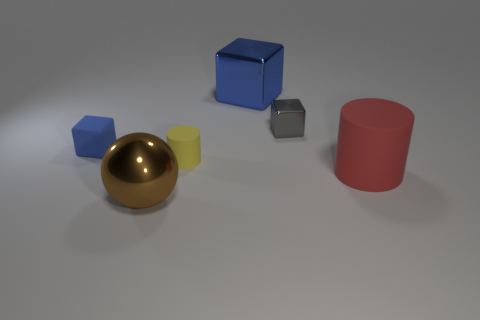What shapes and colors do you observe in the image? The image includes a variety of geometric shapes: a red cylinder, a gold sphere, a yellow and a silver cube, and a blue cube with rounded edges. The colors range from a vibrant blue and red to the more subtle gold, silver, and yellow against a grey backdrop. 